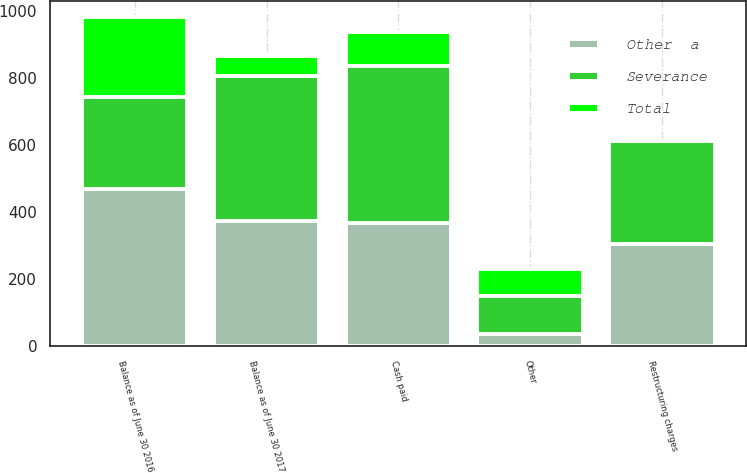Convert chart to OTSL. <chart><loc_0><loc_0><loc_500><loc_500><stacked_bar_chart><ecel><fcel>Balance as of June 30 2016<fcel>Restructuring charges<fcel>Cash paid<fcel>Other<fcel>Balance as of June 30 2017<nl><fcel>Other  a<fcel>470<fcel>306<fcel>367<fcel>36<fcel>373<nl><fcel>Total<fcel>239<fcel>0<fcel>101<fcel>79<fcel>59<nl><fcel>Severance<fcel>272.5<fcel>306<fcel>468<fcel>115<fcel>432<nl></chart> 